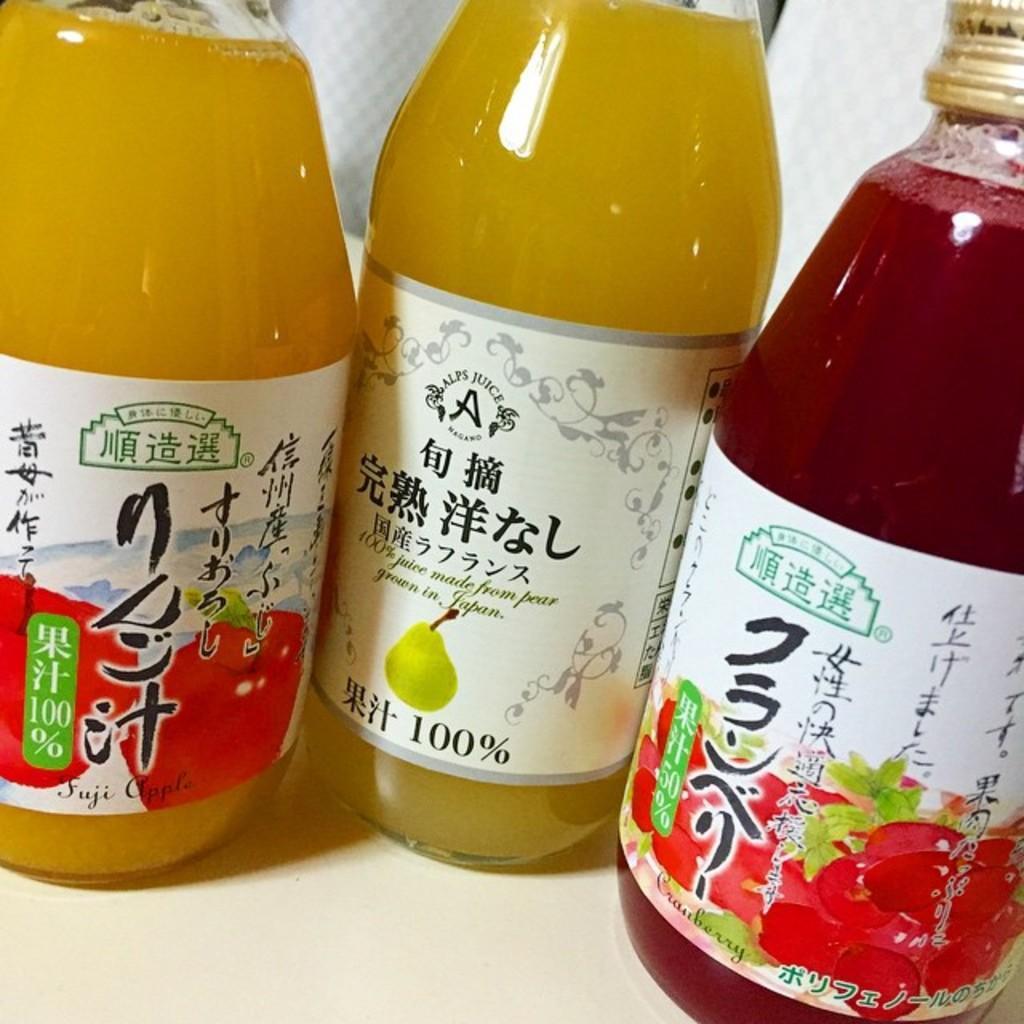Can you describe this image briefly? In this image I can see three bottles with drinks in it. 